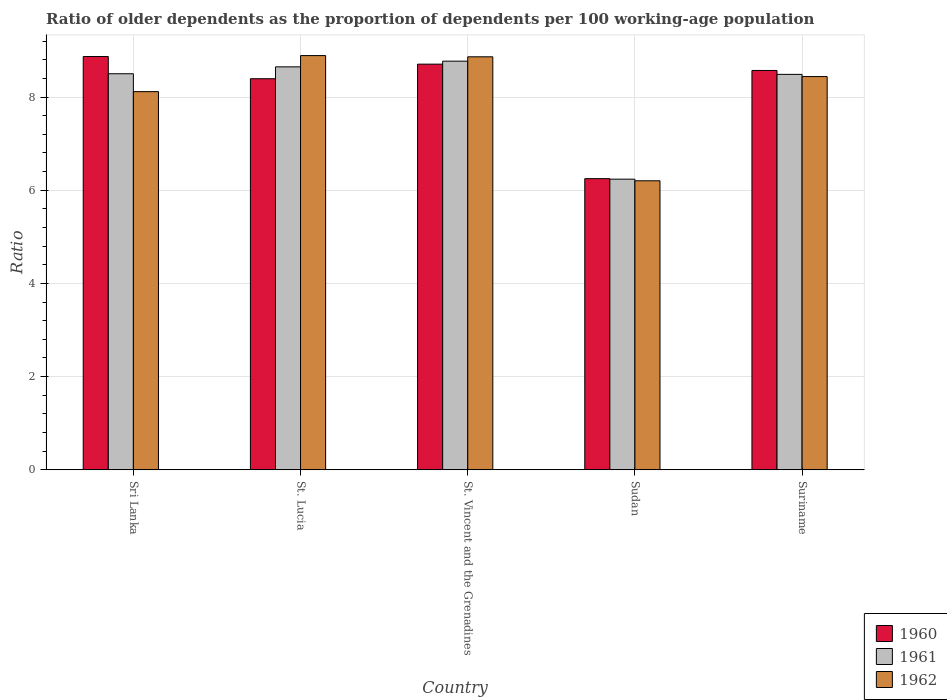How many groups of bars are there?
Ensure brevity in your answer.  5. Are the number of bars on each tick of the X-axis equal?
Provide a succinct answer. Yes. How many bars are there on the 1st tick from the left?
Keep it short and to the point. 3. How many bars are there on the 2nd tick from the right?
Your answer should be very brief. 3. What is the label of the 2nd group of bars from the left?
Provide a succinct answer. St. Lucia. In how many cases, is the number of bars for a given country not equal to the number of legend labels?
Your answer should be compact. 0. What is the age dependency ratio(old) in 1961 in Suriname?
Keep it short and to the point. 8.49. Across all countries, what is the maximum age dependency ratio(old) in 1962?
Your answer should be compact. 8.89. Across all countries, what is the minimum age dependency ratio(old) in 1960?
Your answer should be very brief. 6.25. In which country was the age dependency ratio(old) in 1960 maximum?
Your response must be concise. Sri Lanka. In which country was the age dependency ratio(old) in 1960 minimum?
Your answer should be very brief. Sudan. What is the total age dependency ratio(old) in 1960 in the graph?
Keep it short and to the point. 40.79. What is the difference between the age dependency ratio(old) in 1960 in St. Vincent and the Grenadines and that in Suriname?
Your response must be concise. 0.14. What is the difference between the age dependency ratio(old) in 1960 in Sri Lanka and the age dependency ratio(old) in 1962 in Sudan?
Keep it short and to the point. 2.67. What is the average age dependency ratio(old) in 1962 per country?
Provide a short and direct response. 8.1. What is the difference between the age dependency ratio(old) of/in 1961 and age dependency ratio(old) of/in 1960 in Sudan?
Make the answer very short. -0.01. What is the ratio of the age dependency ratio(old) in 1962 in St. Lucia to that in Suriname?
Your answer should be compact. 1.05. Is the age dependency ratio(old) in 1961 in Sri Lanka less than that in Sudan?
Your answer should be very brief. No. Is the difference between the age dependency ratio(old) in 1961 in Sudan and Suriname greater than the difference between the age dependency ratio(old) in 1960 in Sudan and Suriname?
Your answer should be compact. Yes. What is the difference between the highest and the second highest age dependency ratio(old) in 1962?
Make the answer very short. 0.03. What is the difference between the highest and the lowest age dependency ratio(old) in 1961?
Your answer should be very brief. 2.53. In how many countries, is the age dependency ratio(old) in 1961 greater than the average age dependency ratio(old) in 1961 taken over all countries?
Ensure brevity in your answer.  4. How many countries are there in the graph?
Your answer should be compact. 5. Are the values on the major ticks of Y-axis written in scientific E-notation?
Offer a very short reply. No. Does the graph contain any zero values?
Give a very brief answer. No. Does the graph contain grids?
Offer a terse response. Yes. Where does the legend appear in the graph?
Ensure brevity in your answer.  Bottom right. What is the title of the graph?
Provide a succinct answer. Ratio of older dependents as the proportion of dependents per 100 working-age population. Does "1975" appear as one of the legend labels in the graph?
Ensure brevity in your answer.  No. What is the label or title of the X-axis?
Provide a succinct answer. Country. What is the label or title of the Y-axis?
Your answer should be compact. Ratio. What is the Ratio in 1960 in Sri Lanka?
Your answer should be compact. 8.87. What is the Ratio in 1961 in Sri Lanka?
Provide a short and direct response. 8.5. What is the Ratio in 1962 in Sri Lanka?
Your answer should be very brief. 8.12. What is the Ratio in 1960 in St. Lucia?
Your response must be concise. 8.39. What is the Ratio in 1961 in St. Lucia?
Ensure brevity in your answer.  8.65. What is the Ratio in 1962 in St. Lucia?
Your response must be concise. 8.89. What is the Ratio in 1960 in St. Vincent and the Grenadines?
Give a very brief answer. 8.71. What is the Ratio of 1961 in St. Vincent and the Grenadines?
Make the answer very short. 8.77. What is the Ratio of 1962 in St. Vincent and the Grenadines?
Your answer should be very brief. 8.86. What is the Ratio in 1960 in Sudan?
Offer a terse response. 6.25. What is the Ratio of 1961 in Sudan?
Keep it short and to the point. 6.24. What is the Ratio of 1962 in Sudan?
Offer a terse response. 6.2. What is the Ratio of 1960 in Suriname?
Give a very brief answer. 8.57. What is the Ratio in 1961 in Suriname?
Your answer should be very brief. 8.49. What is the Ratio in 1962 in Suriname?
Your response must be concise. 8.44. Across all countries, what is the maximum Ratio of 1960?
Offer a terse response. 8.87. Across all countries, what is the maximum Ratio in 1961?
Offer a very short reply. 8.77. Across all countries, what is the maximum Ratio of 1962?
Ensure brevity in your answer.  8.89. Across all countries, what is the minimum Ratio in 1960?
Your answer should be compact. 6.25. Across all countries, what is the minimum Ratio of 1961?
Provide a succinct answer. 6.24. Across all countries, what is the minimum Ratio in 1962?
Your answer should be compact. 6.2. What is the total Ratio of 1960 in the graph?
Make the answer very short. 40.79. What is the total Ratio in 1961 in the graph?
Offer a terse response. 40.65. What is the total Ratio of 1962 in the graph?
Keep it short and to the point. 40.52. What is the difference between the Ratio in 1960 in Sri Lanka and that in St. Lucia?
Your answer should be very brief. 0.48. What is the difference between the Ratio in 1961 in Sri Lanka and that in St. Lucia?
Your response must be concise. -0.15. What is the difference between the Ratio in 1962 in Sri Lanka and that in St. Lucia?
Your answer should be compact. -0.77. What is the difference between the Ratio of 1960 in Sri Lanka and that in St. Vincent and the Grenadines?
Offer a very short reply. 0.16. What is the difference between the Ratio of 1961 in Sri Lanka and that in St. Vincent and the Grenadines?
Keep it short and to the point. -0.27. What is the difference between the Ratio in 1962 in Sri Lanka and that in St. Vincent and the Grenadines?
Your response must be concise. -0.75. What is the difference between the Ratio of 1960 in Sri Lanka and that in Sudan?
Your answer should be very brief. 2.62. What is the difference between the Ratio of 1961 in Sri Lanka and that in Sudan?
Your answer should be very brief. 2.26. What is the difference between the Ratio of 1962 in Sri Lanka and that in Sudan?
Make the answer very short. 1.91. What is the difference between the Ratio in 1960 in Sri Lanka and that in Suriname?
Provide a short and direct response. 0.3. What is the difference between the Ratio of 1961 in Sri Lanka and that in Suriname?
Provide a succinct answer. 0.01. What is the difference between the Ratio of 1962 in Sri Lanka and that in Suriname?
Ensure brevity in your answer.  -0.32. What is the difference between the Ratio of 1960 in St. Lucia and that in St. Vincent and the Grenadines?
Offer a terse response. -0.31. What is the difference between the Ratio of 1961 in St. Lucia and that in St. Vincent and the Grenadines?
Keep it short and to the point. -0.12. What is the difference between the Ratio of 1962 in St. Lucia and that in St. Vincent and the Grenadines?
Your response must be concise. 0.03. What is the difference between the Ratio in 1960 in St. Lucia and that in Sudan?
Keep it short and to the point. 2.14. What is the difference between the Ratio of 1961 in St. Lucia and that in Sudan?
Offer a very short reply. 2.41. What is the difference between the Ratio of 1962 in St. Lucia and that in Sudan?
Provide a succinct answer. 2.69. What is the difference between the Ratio of 1960 in St. Lucia and that in Suriname?
Make the answer very short. -0.18. What is the difference between the Ratio in 1961 in St. Lucia and that in Suriname?
Provide a succinct answer. 0.16. What is the difference between the Ratio in 1962 in St. Lucia and that in Suriname?
Provide a short and direct response. 0.45. What is the difference between the Ratio of 1960 in St. Vincent and the Grenadines and that in Sudan?
Offer a terse response. 2.46. What is the difference between the Ratio in 1961 in St. Vincent and the Grenadines and that in Sudan?
Offer a very short reply. 2.53. What is the difference between the Ratio in 1962 in St. Vincent and the Grenadines and that in Sudan?
Provide a short and direct response. 2.66. What is the difference between the Ratio in 1960 in St. Vincent and the Grenadines and that in Suriname?
Your answer should be very brief. 0.14. What is the difference between the Ratio in 1961 in St. Vincent and the Grenadines and that in Suriname?
Keep it short and to the point. 0.28. What is the difference between the Ratio in 1962 in St. Vincent and the Grenadines and that in Suriname?
Your answer should be very brief. 0.42. What is the difference between the Ratio in 1960 in Sudan and that in Suriname?
Offer a very short reply. -2.32. What is the difference between the Ratio in 1961 in Sudan and that in Suriname?
Keep it short and to the point. -2.25. What is the difference between the Ratio in 1962 in Sudan and that in Suriname?
Provide a short and direct response. -2.24. What is the difference between the Ratio in 1960 in Sri Lanka and the Ratio in 1961 in St. Lucia?
Offer a very short reply. 0.22. What is the difference between the Ratio in 1960 in Sri Lanka and the Ratio in 1962 in St. Lucia?
Give a very brief answer. -0.02. What is the difference between the Ratio in 1961 in Sri Lanka and the Ratio in 1962 in St. Lucia?
Ensure brevity in your answer.  -0.39. What is the difference between the Ratio in 1960 in Sri Lanka and the Ratio in 1961 in St. Vincent and the Grenadines?
Your answer should be very brief. 0.1. What is the difference between the Ratio in 1960 in Sri Lanka and the Ratio in 1962 in St. Vincent and the Grenadines?
Provide a short and direct response. 0.01. What is the difference between the Ratio in 1961 in Sri Lanka and the Ratio in 1962 in St. Vincent and the Grenadines?
Keep it short and to the point. -0.36. What is the difference between the Ratio in 1960 in Sri Lanka and the Ratio in 1961 in Sudan?
Your answer should be very brief. 2.63. What is the difference between the Ratio of 1960 in Sri Lanka and the Ratio of 1962 in Sudan?
Keep it short and to the point. 2.67. What is the difference between the Ratio in 1961 in Sri Lanka and the Ratio in 1962 in Sudan?
Your answer should be very brief. 2.3. What is the difference between the Ratio in 1960 in Sri Lanka and the Ratio in 1961 in Suriname?
Give a very brief answer. 0.38. What is the difference between the Ratio in 1960 in Sri Lanka and the Ratio in 1962 in Suriname?
Give a very brief answer. 0.43. What is the difference between the Ratio in 1961 in Sri Lanka and the Ratio in 1962 in Suriname?
Provide a succinct answer. 0.06. What is the difference between the Ratio of 1960 in St. Lucia and the Ratio of 1961 in St. Vincent and the Grenadines?
Offer a very short reply. -0.38. What is the difference between the Ratio in 1960 in St. Lucia and the Ratio in 1962 in St. Vincent and the Grenadines?
Make the answer very short. -0.47. What is the difference between the Ratio in 1961 in St. Lucia and the Ratio in 1962 in St. Vincent and the Grenadines?
Offer a terse response. -0.22. What is the difference between the Ratio of 1960 in St. Lucia and the Ratio of 1961 in Sudan?
Your answer should be very brief. 2.16. What is the difference between the Ratio of 1960 in St. Lucia and the Ratio of 1962 in Sudan?
Keep it short and to the point. 2.19. What is the difference between the Ratio in 1961 in St. Lucia and the Ratio in 1962 in Sudan?
Provide a succinct answer. 2.45. What is the difference between the Ratio in 1960 in St. Lucia and the Ratio in 1961 in Suriname?
Make the answer very short. -0.09. What is the difference between the Ratio in 1960 in St. Lucia and the Ratio in 1962 in Suriname?
Your response must be concise. -0.05. What is the difference between the Ratio of 1961 in St. Lucia and the Ratio of 1962 in Suriname?
Offer a terse response. 0.21. What is the difference between the Ratio of 1960 in St. Vincent and the Grenadines and the Ratio of 1961 in Sudan?
Your answer should be compact. 2.47. What is the difference between the Ratio in 1960 in St. Vincent and the Grenadines and the Ratio in 1962 in Sudan?
Offer a very short reply. 2.5. What is the difference between the Ratio of 1961 in St. Vincent and the Grenadines and the Ratio of 1962 in Sudan?
Make the answer very short. 2.57. What is the difference between the Ratio of 1960 in St. Vincent and the Grenadines and the Ratio of 1961 in Suriname?
Provide a short and direct response. 0.22. What is the difference between the Ratio in 1960 in St. Vincent and the Grenadines and the Ratio in 1962 in Suriname?
Give a very brief answer. 0.27. What is the difference between the Ratio in 1961 in St. Vincent and the Grenadines and the Ratio in 1962 in Suriname?
Offer a very short reply. 0.33. What is the difference between the Ratio of 1960 in Sudan and the Ratio of 1961 in Suriname?
Your response must be concise. -2.24. What is the difference between the Ratio in 1960 in Sudan and the Ratio in 1962 in Suriname?
Ensure brevity in your answer.  -2.19. What is the difference between the Ratio of 1961 in Sudan and the Ratio of 1962 in Suriname?
Your response must be concise. -2.2. What is the average Ratio in 1960 per country?
Ensure brevity in your answer.  8.16. What is the average Ratio in 1961 per country?
Offer a terse response. 8.13. What is the average Ratio in 1962 per country?
Keep it short and to the point. 8.1. What is the difference between the Ratio of 1960 and Ratio of 1961 in Sri Lanka?
Offer a terse response. 0.37. What is the difference between the Ratio in 1960 and Ratio in 1962 in Sri Lanka?
Provide a succinct answer. 0.75. What is the difference between the Ratio of 1961 and Ratio of 1962 in Sri Lanka?
Your answer should be very brief. 0.38. What is the difference between the Ratio of 1960 and Ratio of 1961 in St. Lucia?
Give a very brief answer. -0.26. What is the difference between the Ratio of 1960 and Ratio of 1962 in St. Lucia?
Your answer should be compact. -0.5. What is the difference between the Ratio of 1961 and Ratio of 1962 in St. Lucia?
Your answer should be compact. -0.24. What is the difference between the Ratio of 1960 and Ratio of 1961 in St. Vincent and the Grenadines?
Make the answer very short. -0.06. What is the difference between the Ratio in 1960 and Ratio in 1962 in St. Vincent and the Grenadines?
Ensure brevity in your answer.  -0.16. What is the difference between the Ratio of 1961 and Ratio of 1962 in St. Vincent and the Grenadines?
Your response must be concise. -0.09. What is the difference between the Ratio of 1960 and Ratio of 1961 in Sudan?
Give a very brief answer. 0.01. What is the difference between the Ratio in 1960 and Ratio in 1962 in Sudan?
Provide a succinct answer. 0.05. What is the difference between the Ratio in 1961 and Ratio in 1962 in Sudan?
Ensure brevity in your answer.  0.04. What is the difference between the Ratio of 1960 and Ratio of 1961 in Suriname?
Offer a terse response. 0.08. What is the difference between the Ratio in 1960 and Ratio in 1962 in Suriname?
Make the answer very short. 0.13. What is the difference between the Ratio of 1961 and Ratio of 1962 in Suriname?
Keep it short and to the point. 0.05. What is the ratio of the Ratio of 1960 in Sri Lanka to that in St. Lucia?
Ensure brevity in your answer.  1.06. What is the ratio of the Ratio in 1961 in Sri Lanka to that in St. Lucia?
Your response must be concise. 0.98. What is the ratio of the Ratio of 1960 in Sri Lanka to that in St. Vincent and the Grenadines?
Provide a succinct answer. 1.02. What is the ratio of the Ratio of 1961 in Sri Lanka to that in St. Vincent and the Grenadines?
Give a very brief answer. 0.97. What is the ratio of the Ratio of 1962 in Sri Lanka to that in St. Vincent and the Grenadines?
Offer a terse response. 0.92. What is the ratio of the Ratio of 1960 in Sri Lanka to that in Sudan?
Make the answer very short. 1.42. What is the ratio of the Ratio of 1961 in Sri Lanka to that in Sudan?
Your answer should be compact. 1.36. What is the ratio of the Ratio in 1962 in Sri Lanka to that in Sudan?
Provide a short and direct response. 1.31. What is the ratio of the Ratio in 1960 in Sri Lanka to that in Suriname?
Your response must be concise. 1.03. What is the ratio of the Ratio in 1961 in Sri Lanka to that in Suriname?
Your response must be concise. 1. What is the ratio of the Ratio in 1962 in Sri Lanka to that in Suriname?
Give a very brief answer. 0.96. What is the ratio of the Ratio of 1960 in St. Lucia to that in St. Vincent and the Grenadines?
Keep it short and to the point. 0.96. What is the ratio of the Ratio of 1961 in St. Lucia to that in St. Vincent and the Grenadines?
Provide a succinct answer. 0.99. What is the ratio of the Ratio in 1962 in St. Lucia to that in St. Vincent and the Grenadines?
Provide a short and direct response. 1. What is the ratio of the Ratio of 1960 in St. Lucia to that in Sudan?
Provide a short and direct response. 1.34. What is the ratio of the Ratio in 1961 in St. Lucia to that in Sudan?
Provide a succinct answer. 1.39. What is the ratio of the Ratio in 1962 in St. Lucia to that in Sudan?
Ensure brevity in your answer.  1.43. What is the ratio of the Ratio in 1960 in St. Lucia to that in Suriname?
Keep it short and to the point. 0.98. What is the ratio of the Ratio of 1962 in St. Lucia to that in Suriname?
Provide a short and direct response. 1.05. What is the ratio of the Ratio of 1960 in St. Vincent and the Grenadines to that in Sudan?
Give a very brief answer. 1.39. What is the ratio of the Ratio of 1961 in St. Vincent and the Grenadines to that in Sudan?
Ensure brevity in your answer.  1.41. What is the ratio of the Ratio in 1962 in St. Vincent and the Grenadines to that in Sudan?
Ensure brevity in your answer.  1.43. What is the ratio of the Ratio in 1960 in St. Vincent and the Grenadines to that in Suriname?
Offer a very short reply. 1.02. What is the ratio of the Ratio of 1961 in St. Vincent and the Grenadines to that in Suriname?
Provide a short and direct response. 1.03. What is the ratio of the Ratio in 1962 in St. Vincent and the Grenadines to that in Suriname?
Your response must be concise. 1.05. What is the ratio of the Ratio of 1960 in Sudan to that in Suriname?
Your answer should be very brief. 0.73. What is the ratio of the Ratio in 1961 in Sudan to that in Suriname?
Keep it short and to the point. 0.73. What is the ratio of the Ratio of 1962 in Sudan to that in Suriname?
Ensure brevity in your answer.  0.73. What is the difference between the highest and the second highest Ratio in 1960?
Provide a short and direct response. 0.16. What is the difference between the highest and the second highest Ratio in 1961?
Provide a short and direct response. 0.12. What is the difference between the highest and the second highest Ratio in 1962?
Your answer should be very brief. 0.03. What is the difference between the highest and the lowest Ratio of 1960?
Your response must be concise. 2.62. What is the difference between the highest and the lowest Ratio in 1961?
Offer a very short reply. 2.53. What is the difference between the highest and the lowest Ratio in 1962?
Offer a terse response. 2.69. 